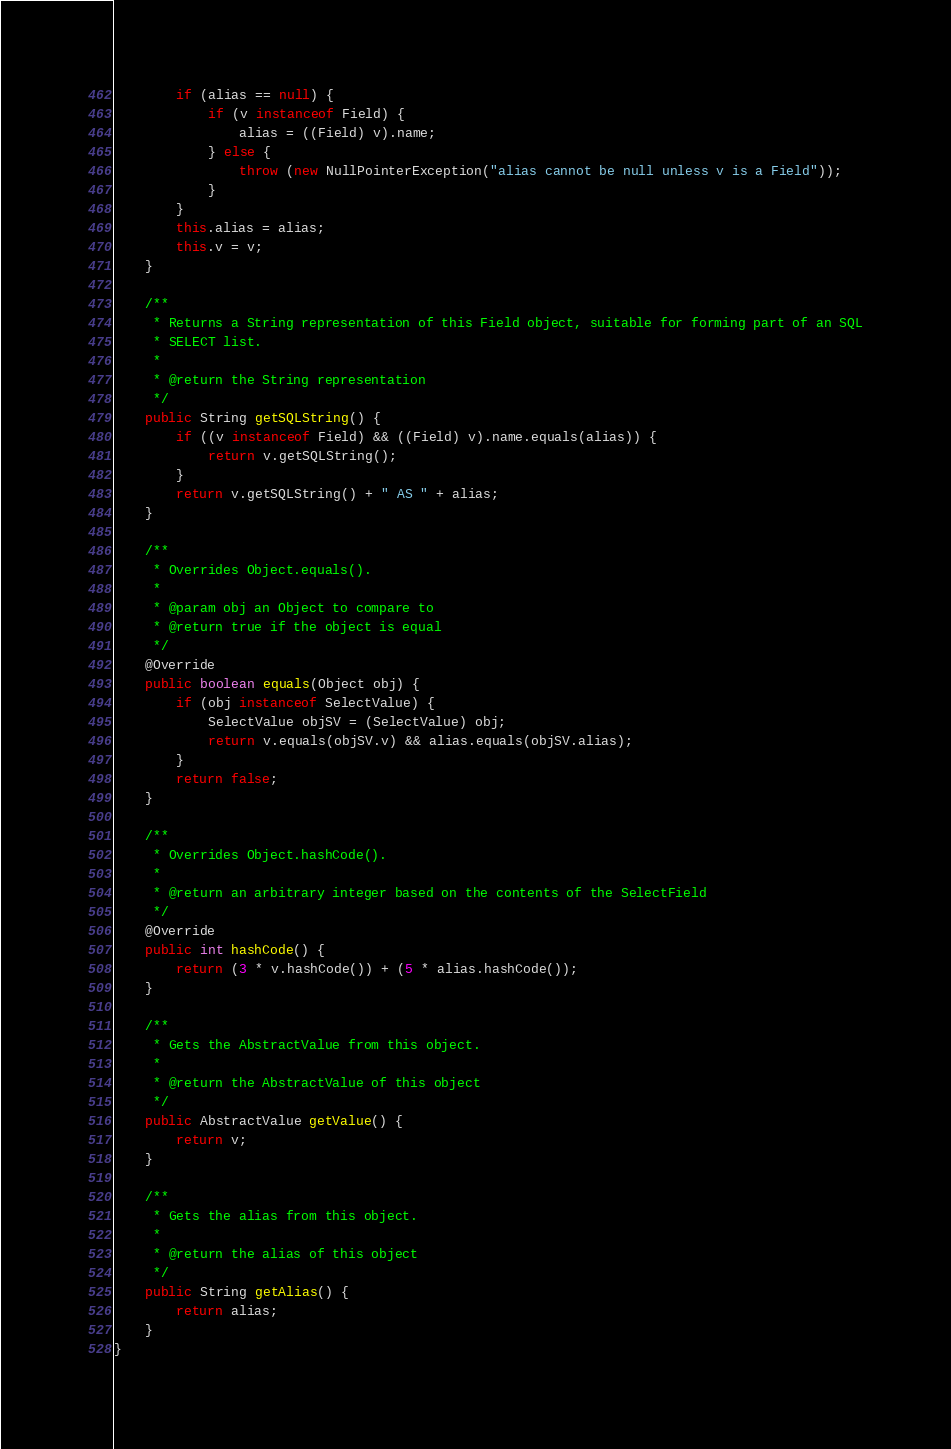Convert code to text. <code><loc_0><loc_0><loc_500><loc_500><_Java_>        if (alias == null) {
            if (v instanceof Field) {
                alias = ((Field) v).name;
            } else {
                throw (new NullPointerException("alias cannot be null unless v is a Field"));
            }
        }
        this.alias = alias;
        this.v = v;
    }

    /**
     * Returns a String representation of this Field object, suitable for forming part of an SQL
     * SELECT list.
     *
     * @return the String representation
     */
    public String getSQLString() {
        if ((v instanceof Field) && ((Field) v).name.equals(alias)) {
            return v.getSQLString();
        }
        return v.getSQLString() + " AS " + alias;
    }

    /**
     * Overrides Object.equals().
     *
     * @param obj an Object to compare to
     * @return true if the object is equal
     */
    @Override
    public boolean equals(Object obj) {
        if (obj instanceof SelectValue) {
            SelectValue objSV = (SelectValue) obj;
            return v.equals(objSV.v) && alias.equals(objSV.alias);
        }
        return false;
    }

    /**
     * Overrides Object.hashCode().
     *
     * @return an arbitrary integer based on the contents of the SelectField
     */
    @Override
    public int hashCode() {
        return (3 * v.hashCode()) + (5 * alias.hashCode());
    }

    /**
     * Gets the AbstractValue from this object.
     *
     * @return the AbstractValue of this object
     */
    public AbstractValue getValue() {
        return v;
    }

    /**
     * Gets the alias from this object.
     *
     * @return the alias of this object
     */
    public String getAlias() {
        return alias;
    }
}
</code> 